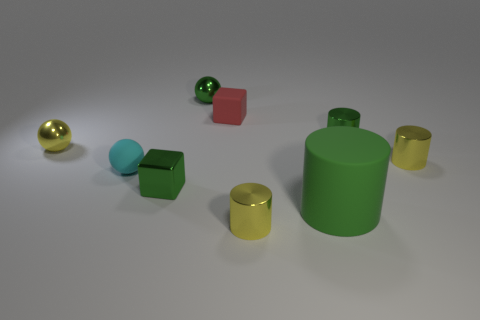Subtract 1 cylinders. How many cylinders are left? 3 Add 1 tiny blue matte cubes. How many objects exist? 10 Subtract all spheres. How many objects are left? 6 Subtract all big green objects. Subtract all large blue rubber blocks. How many objects are left? 8 Add 5 cyan things. How many cyan things are left? 6 Add 8 cyan spheres. How many cyan spheres exist? 9 Subtract 1 red blocks. How many objects are left? 8 